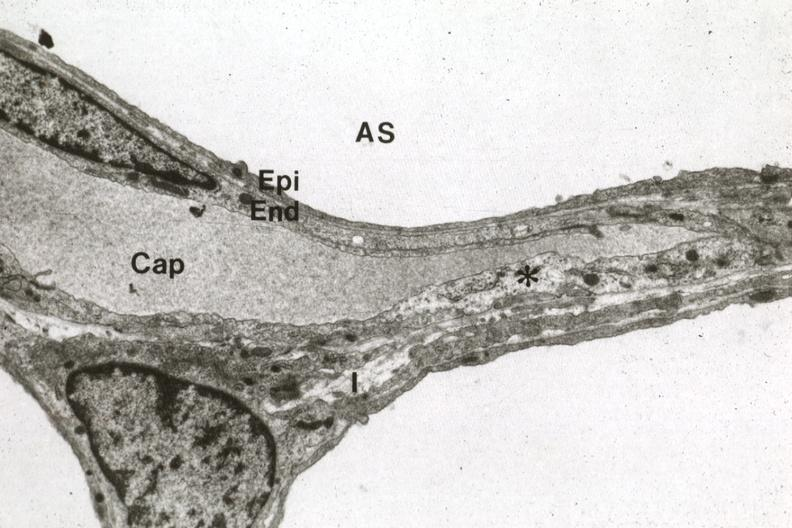s respiratory present?
Answer the question using a single word or phrase. Yes 